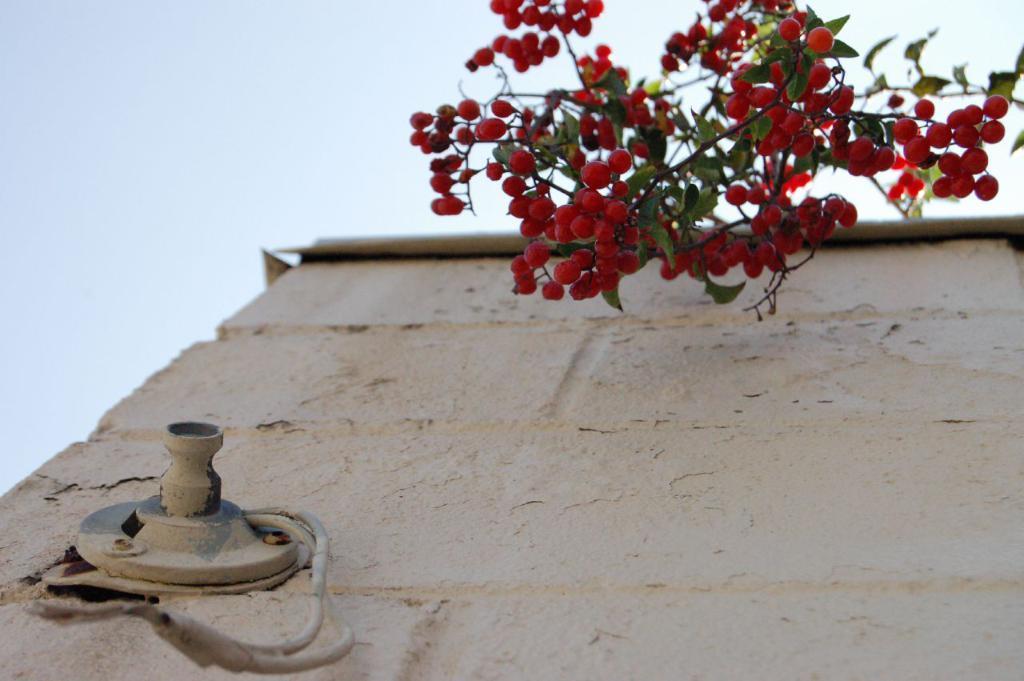In one or two sentences, can you explain what this image depicts? In this image, we can see a wall. Here there is an object and wires we can see. Top of the image, we can see red color fruits with stems and leaves. Background there is a sky. 